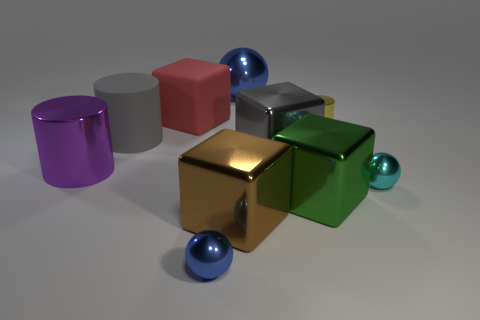Subtract all balls. How many objects are left? 7 Subtract 1 yellow cylinders. How many objects are left? 9 Subtract all gray metallic cubes. Subtract all metal cubes. How many objects are left? 6 Add 6 small cyan balls. How many small cyan balls are left? 7 Add 1 yellow objects. How many yellow objects exist? 2 